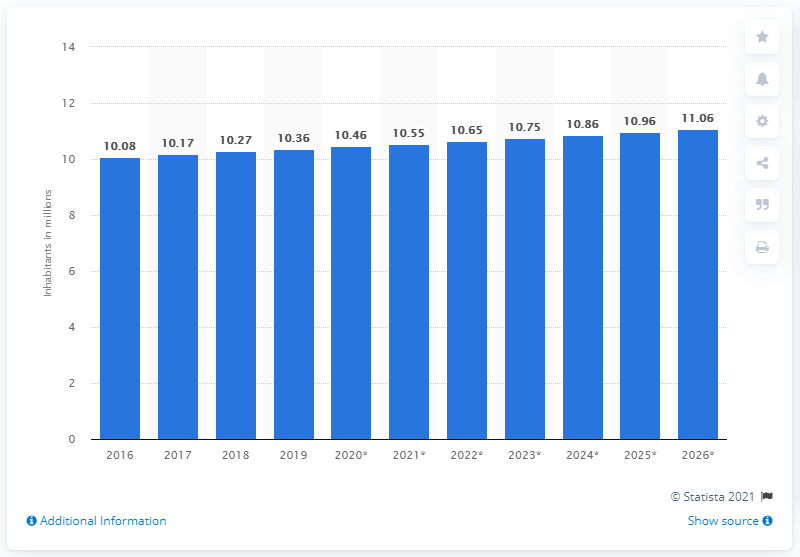Identify some key points in this picture. The population of the Dominican Republic in 2019 was 10,463,791. 